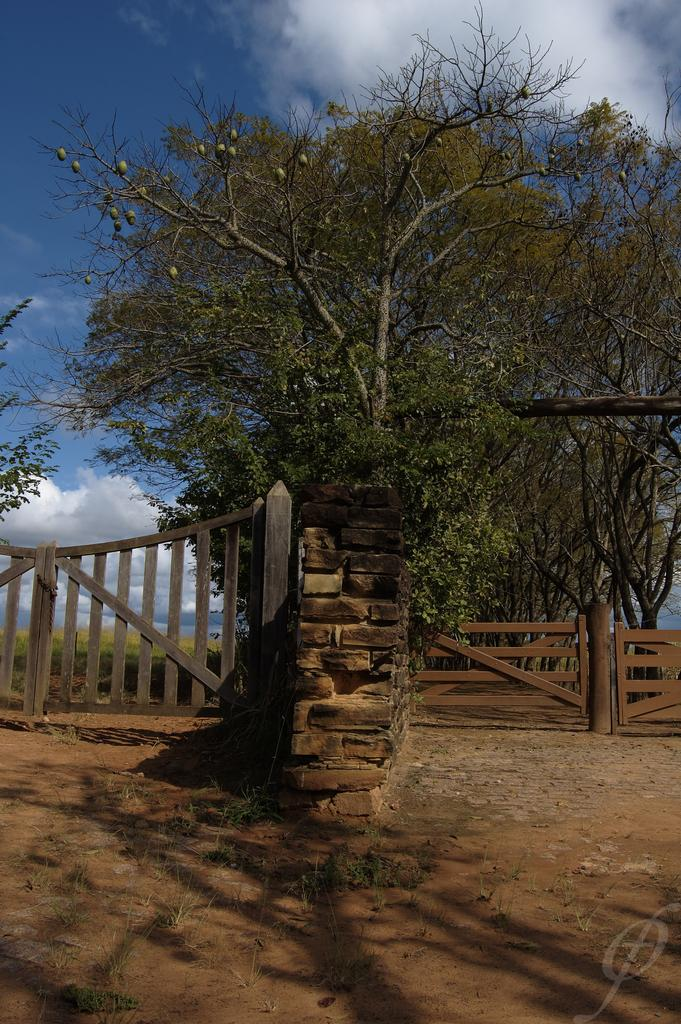What type of structure is present in the image? There is a wooden gate in the image. What other type of structure can be seen in the image? There is a brick wall in the image. What natural elements are present in the image? There are trees in the image. What type of decision can be seen being made by the animal in the image? There is no animal present in the image, so no decision can be observed. 